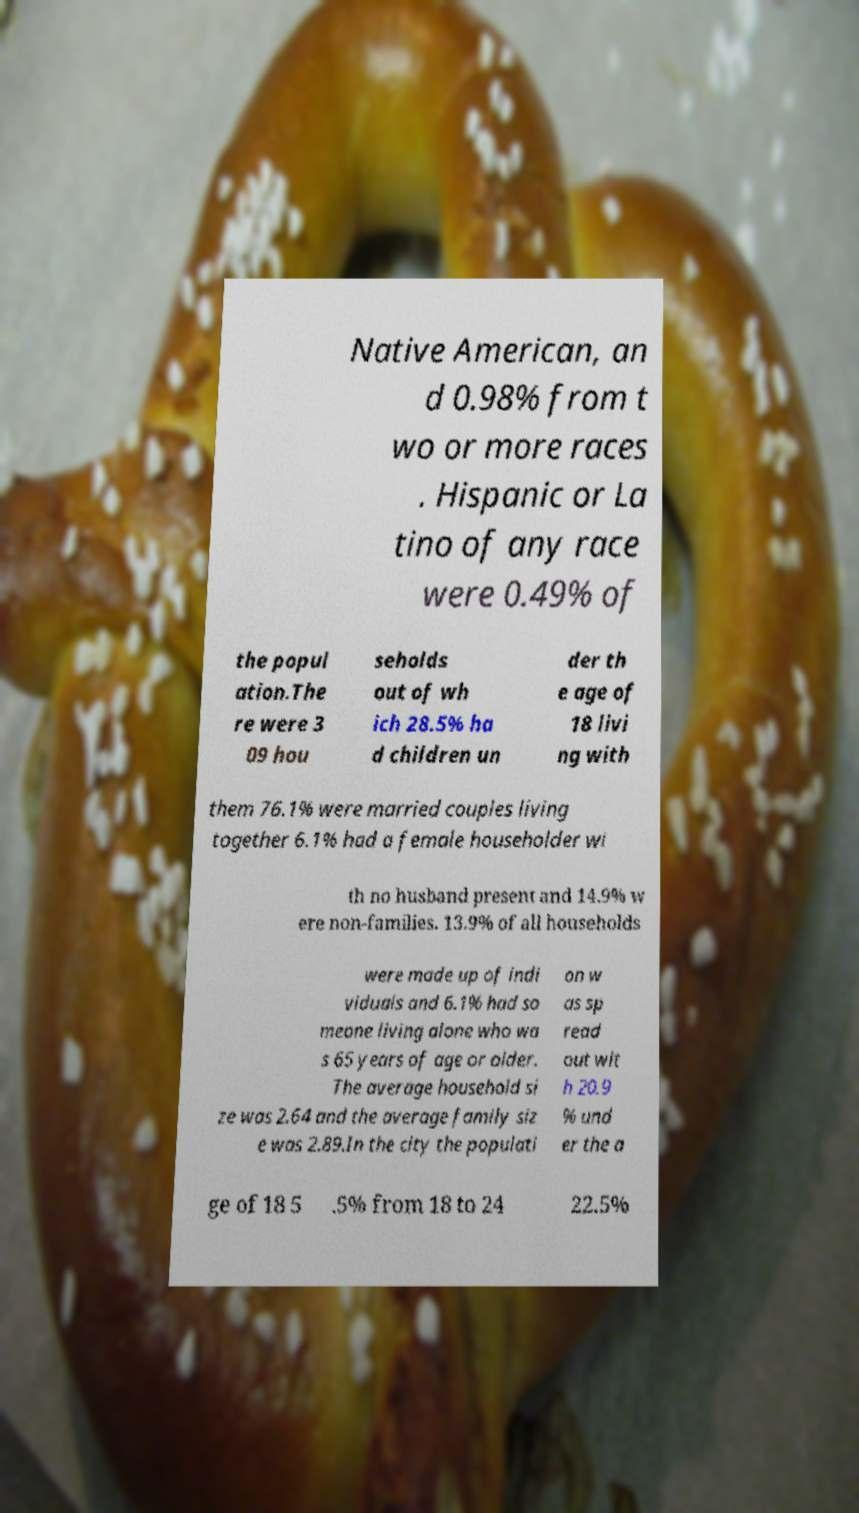Can you read and provide the text displayed in the image?This photo seems to have some interesting text. Can you extract and type it out for me? Native American, an d 0.98% from t wo or more races . Hispanic or La tino of any race were 0.49% of the popul ation.The re were 3 09 hou seholds out of wh ich 28.5% ha d children un der th e age of 18 livi ng with them 76.1% were married couples living together 6.1% had a female householder wi th no husband present and 14.9% w ere non-families. 13.9% of all households were made up of indi viduals and 6.1% had so meone living alone who wa s 65 years of age or older. The average household si ze was 2.64 and the average family siz e was 2.89.In the city the populati on w as sp read out wit h 20.9 % und er the a ge of 18 5 .5% from 18 to 24 22.5% 